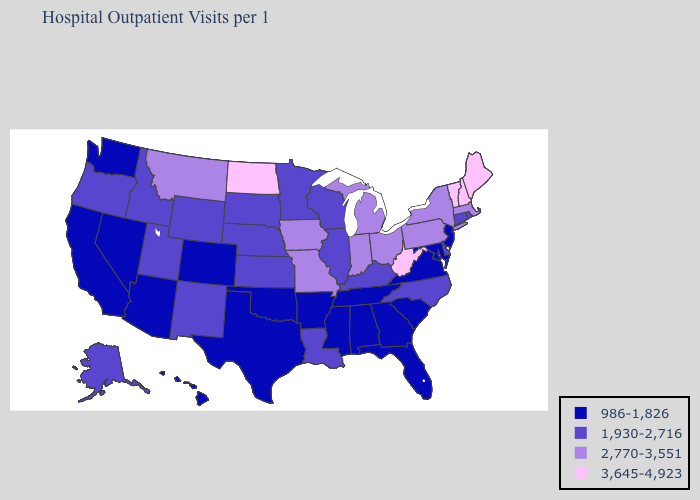What is the value of Missouri?
Short answer required. 2,770-3,551. What is the value of Kansas?
Be succinct. 1,930-2,716. Name the states that have a value in the range 2,770-3,551?
Concise answer only. Indiana, Iowa, Massachusetts, Michigan, Missouri, Montana, New York, Ohio, Pennsylvania. What is the highest value in states that border West Virginia?
Answer briefly. 2,770-3,551. Among the states that border New Mexico , which have the lowest value?
Concise answer only. Arizona, Colorado, Oklahoma, Texas. Does Michigan have a lower value than Vermont?
Concise answer only. Yes. What is the highest value in the MidWest ?
Write a very short answer. 3,645-4,923. Does Arkansas have the lowest value in the South?
Be succinct. Yes. Name the states that have a value in the range 2,770-3,551?
Answer briefly. Indiana, Iowa, Massachusetts, Michigan, Missouri, Montana, New York, Ohio, Pennsylvania. What is the highest value in states that border North Carolina?
Write a very short answer. 986-1,826. What is the value of Nebraska?
Give a very brief answer. 1,930-2,716. What is the value of Iowa?
Keep it brief. 2,770-3,551. Name the states that have a value in the range 2,770-3,551?
Keep it brief. Indiana, Iowa, Massachusetts, Michigan, Missouri, Montana, New York, Ohio, Pennsylvania. Name the states that have a value in the range 3,645-4,923?
Be succinct. Maine, New Hampshire, North Dakota, Vermont, West Virginia. 